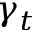<formula> <loc_0><loc_0><loc_500><loc_500>\gamma _ { t }</formula> 